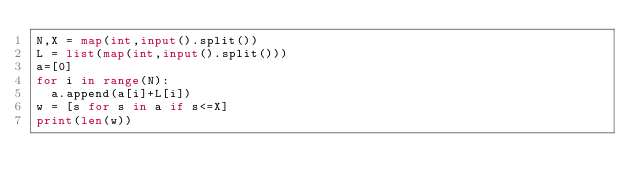Convert code to text. <code><loc_0><loc_0><loc_500><loc_500><_Python_>N,X = map(int,input().split())
L = list(map(int,input().split()))
a=[0]
for i in range(N):
  a.append(a[i]+L[i])
w = [s for s in a if s<=X]
print(len(w))</code> 